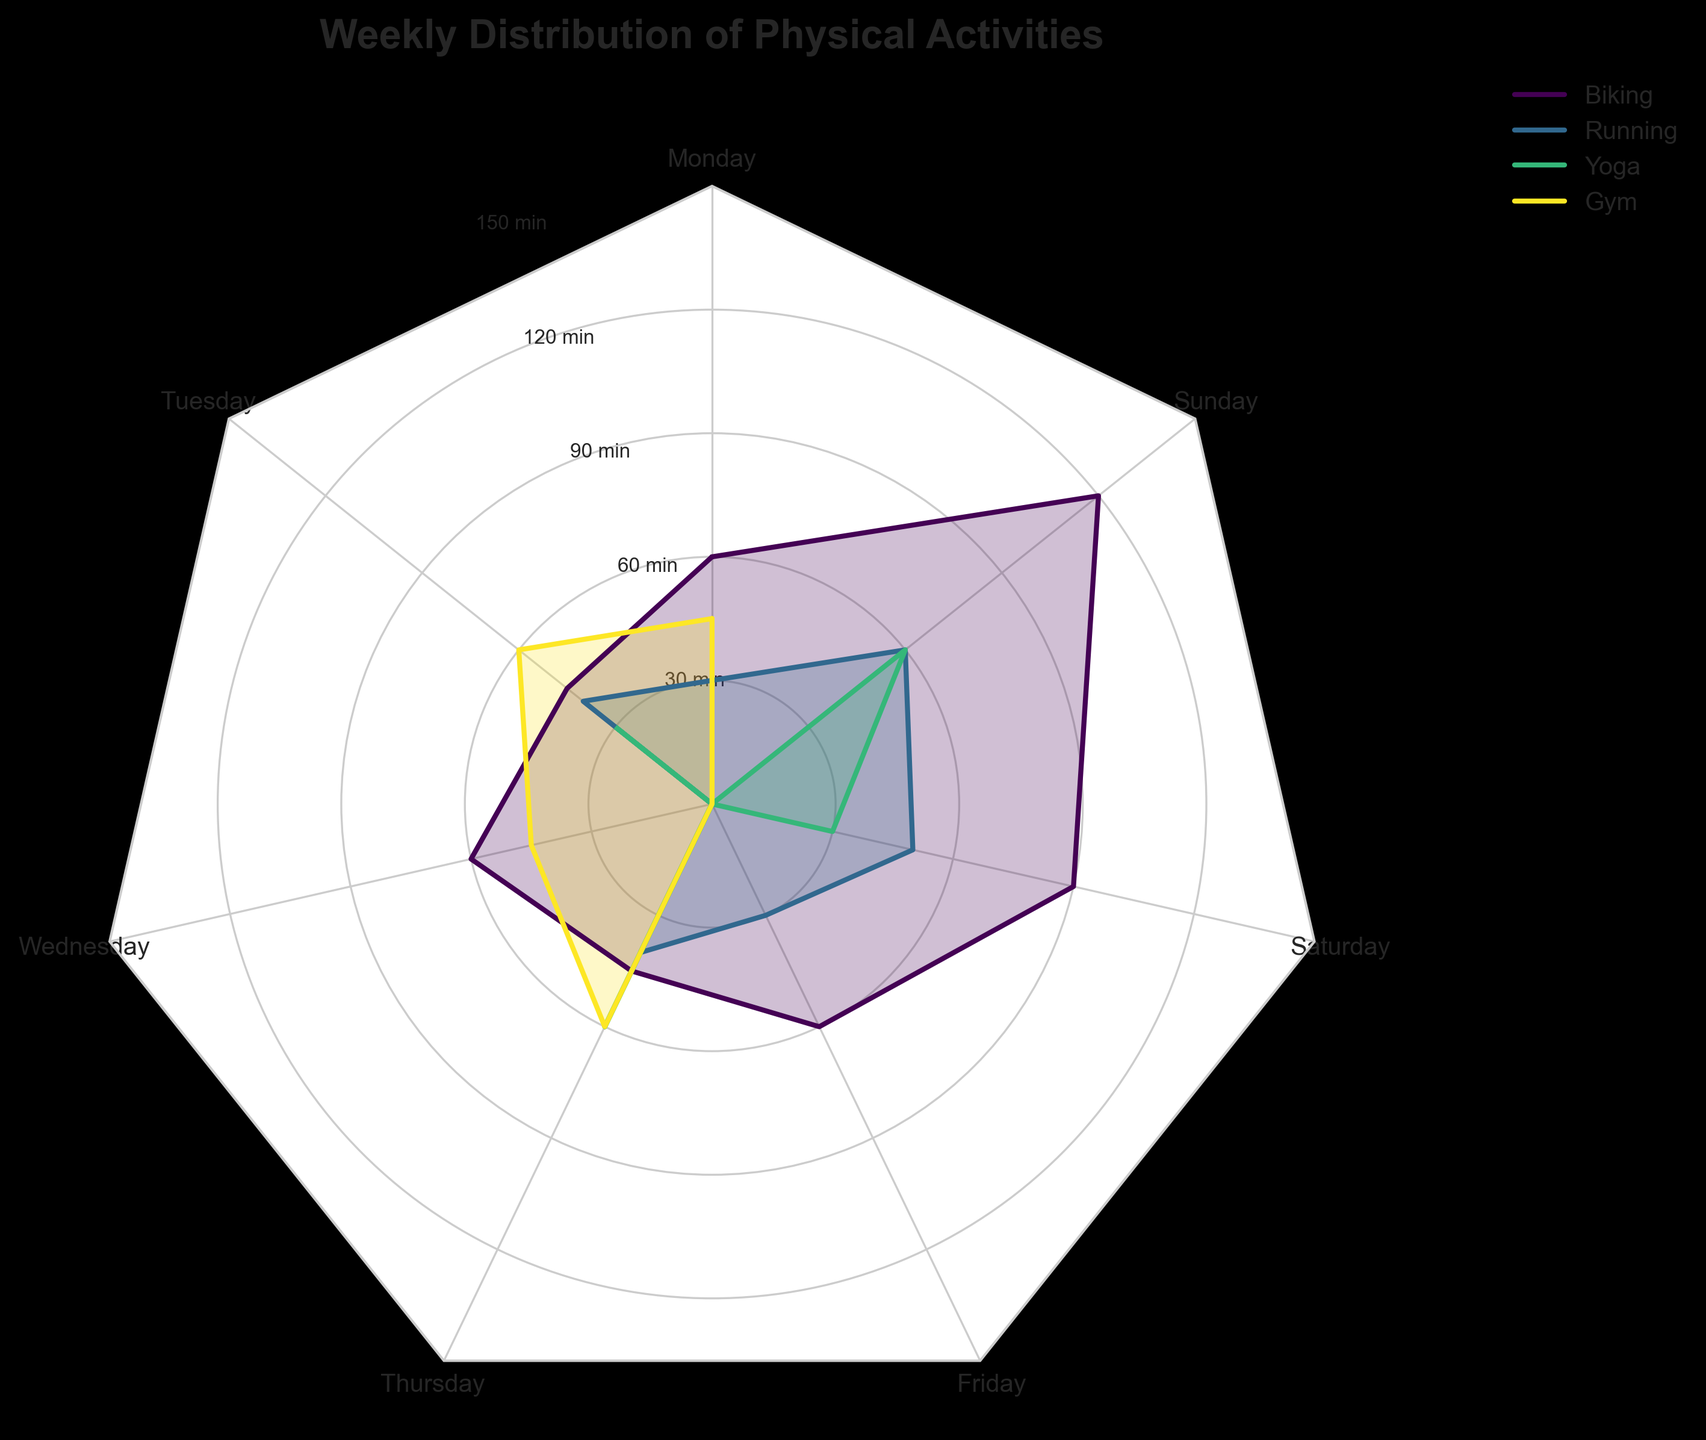what is the title of the figure? The title is written at the top of the figure and should be in a bold font style to easily identify it.
Answer: Weekly Distribution of Physical Activities How many activities are plotted in the radar chart? The radar chart shows distinct lines and filled areas for each activity, and the legend also lists each activity by name. Count the different line patterns and labels in the legend.
Answer: 4 Which activity has the highest value on Sunday? Look for the point on the radar chart corresponding to Sunday and compare the values of different activities. The legend color-codes the activities for easy reference.
Answer: Biking What is the total time spent on yoga throughout the week? Check the value of Yoga for each day and sum them up: 0 (Monday) + 30 (Tuesday) + 0 (Wednesday) + 60 (Thursday) + 0 (Friday) + 30 (Saturday) + 60 (Sunday).
Answer: 180 minutes Which day has the highest total time spent across all activities? For each day, sum up the time spent on all activities and compare the sums. The day with the highest total is the result.
Answer: Sunday How does the time spent running on Tuesday compare to the time spent in the gym on Tuesday? Find the value for Running and Gym on Tuesday, then compare these two values.
Answer: Running: 40 minutes, Gym: 60 minutes On which days is no time spent at the gym? Identify the points where the value for Gym is zero. These points correspond to the days when there was no time spent at the gym.
Answer: Friday, Saturday, Sunday What’s the average time spent on biking throughout the week? Add up the minutes spent biking each day and divide by the number of days: (60 + 45 + 60 + 45 + 60 + 90 + 120) / 7.
Answer: 68.57 minutes Which activity has the most consistent weekly schedule? Look for the activity with the least fluctuation in values across the days in the radar chart. Examine the lines for steady, almost even distribution throughout the week.
Answer: Gym Between running and yoga, which activity has a higher total time from Monday to Wednesday? Sum up the values from Monday to Wednesday for each activity and compare: Running: (30 + 40 + 0) vs Yoga: (0 + 30 + 0).
Answer: Running: 70 minutes, Yoga: 30 minutes 